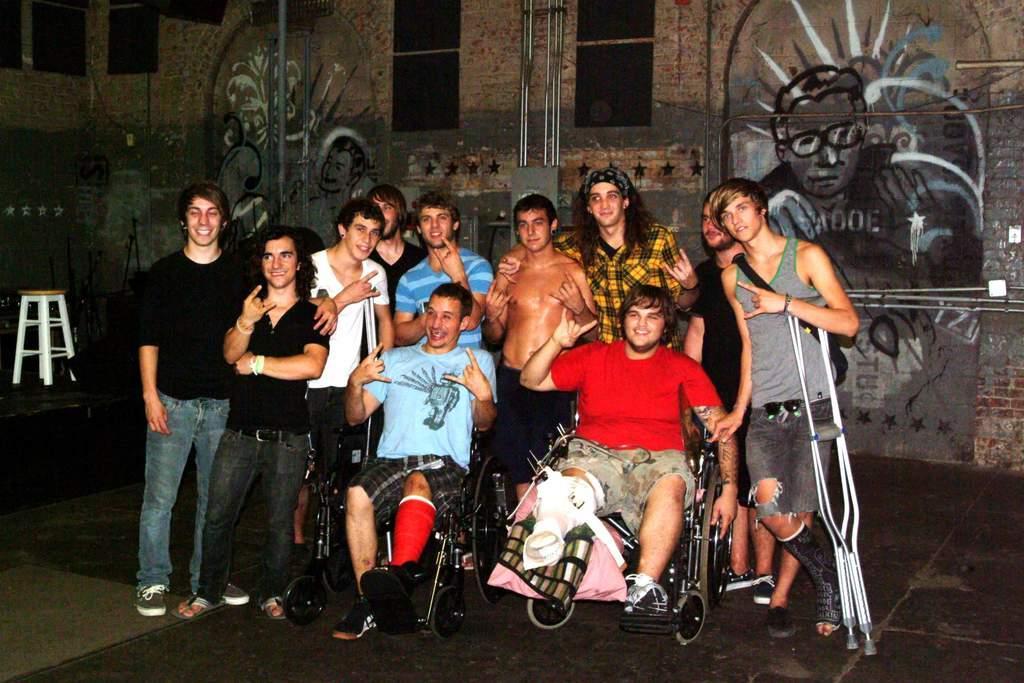Could you give a brief overview of what you see in this image? In this picture I can see 2 men in front who are sitting on wheel chairs and beside to them I can see a man who is holding walking sticks and I see rest of them men are standing behind them and I see that all of them are smiling. In the background I can see the wall and I see an art on it and on the left side of this picture I can see a stool. 